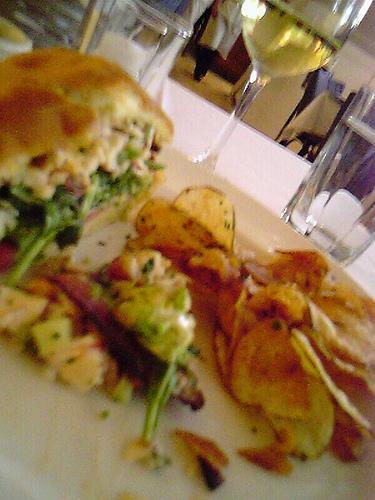Is there alcohol in this photo?
Be succinct. Yes. Is there a glass in the photo?
Quick response, please. Yes. What kind of potatoes are on the plate?
Write a very short answer. Chips. 